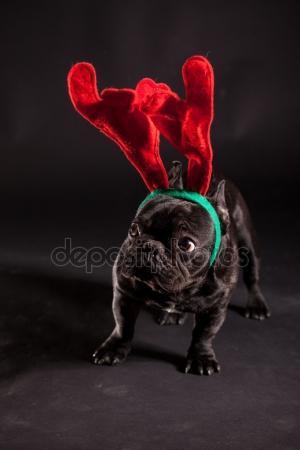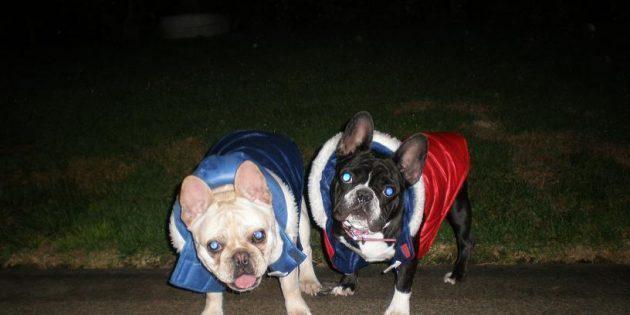The first image is the image on the left, the second image is the image on the right. Evaluate the accuracy of this statement regarding the images: "Each dog is wearing some kind of costume.". Is it true? Answer yes or no. Yes. 